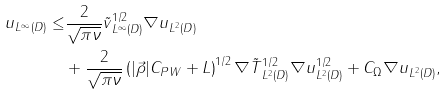Convert formula to latex. <formula><loc_0><loc_0><loc_500><loc_500>\| u \| _ { L ^ { \infty } ( D ) } \leq & \frac { 2 } { \sqrt { \pi \nu } } \| \tilde { v } \| _ { L ^ { \infty } ( D ) } ^ { 1 / 2 } \| \nabla u \| _ { L ^ { 2 } ( D ) } \\ & + \frac { 2 } { \sqrt { \pi \nu } } \left ( | \vec { \rho } | C _ { P W } + L \right ) ^ { 1 / 2 } \| \nabla \tilde { T } \| _ { L ^ { 2 } ( D ) } ^ { 1 / 2 } \| \nabla u \| _ { L ^ { 2 } ( D ) } ^ { 1 / 2 } + C _ { \Omega } \| \nabla u \| _ { L ^ { 2 } ( D ) } ,</formula> 